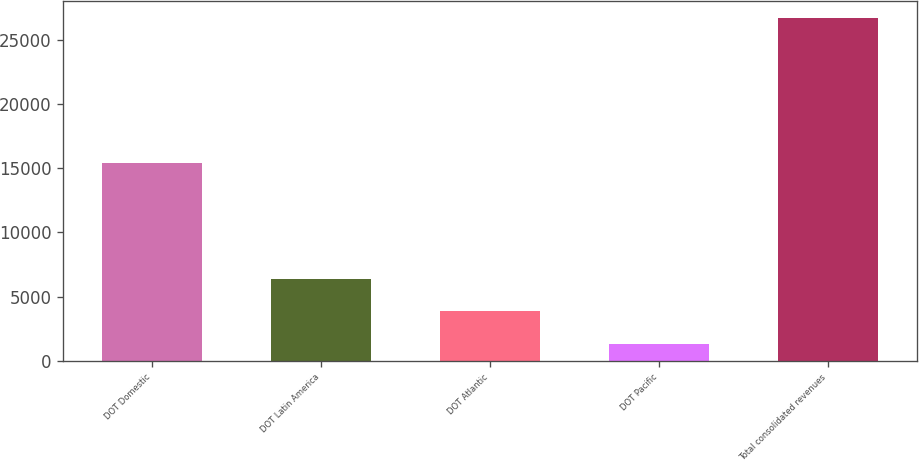<chart> <loc_0><loc_0><loc_500><loc_500><bar_chart><fcel>DOT Domestic<fcel>DOT Latin America<fcel>DOT Atlantic<fcel>DOT Pacific<fcel>Total consolidated revenues<nl><fcel>15376<fcel>6407<fcel>3865<fcel>1323<fcel>26743<nl></chart> 